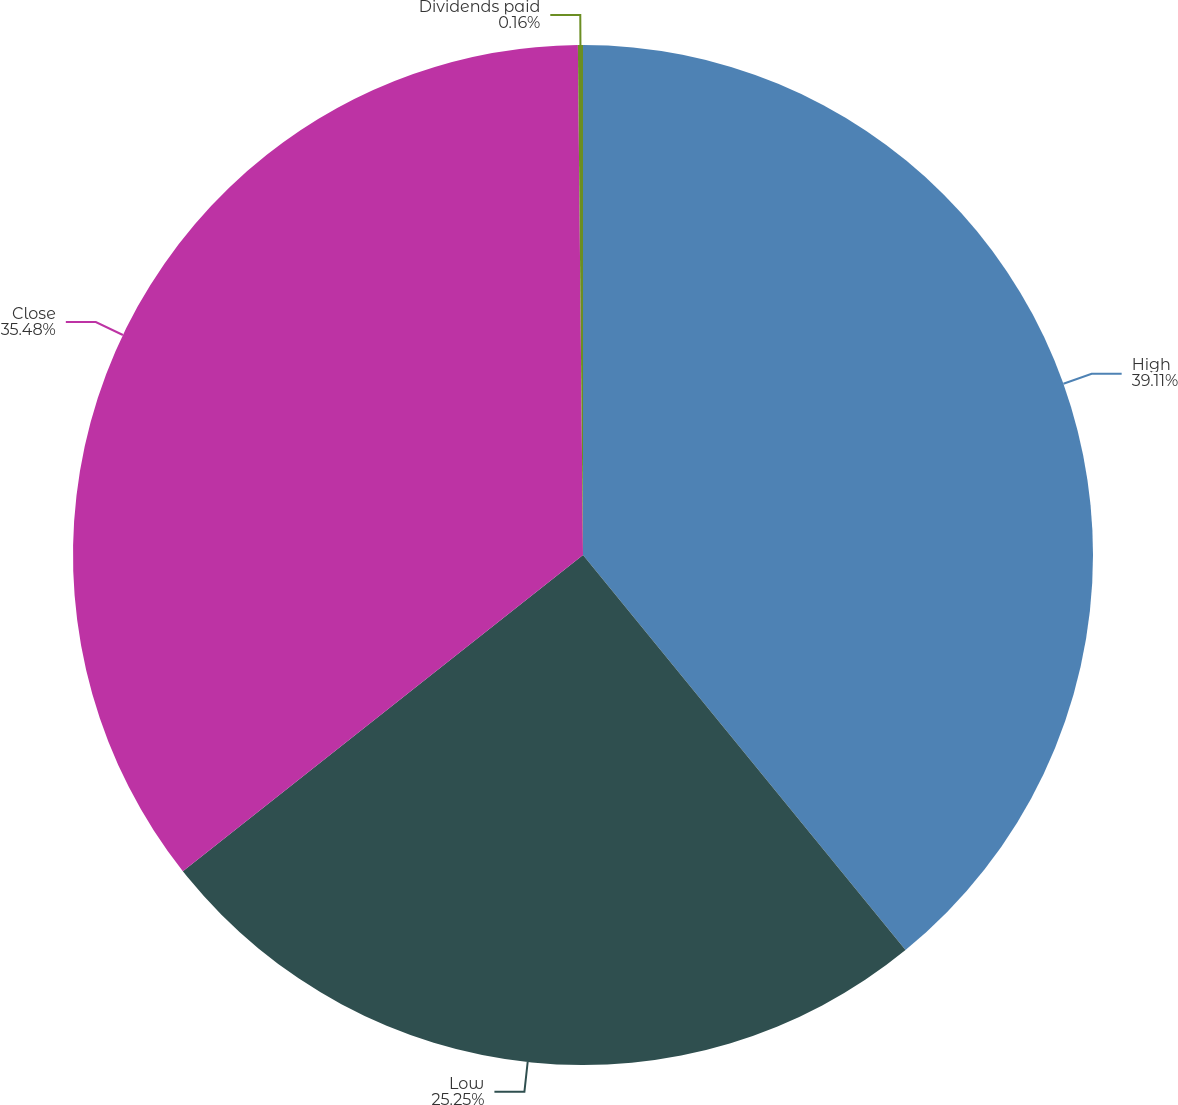<chart> <loc_0><loc_0><loc_500><loc_500><pie_chart><fcel>High<fcel>Low<fcel>Close<fcel>Dividends paid<nl><fcel>39.1%<fcel>25.25%<fcel>35.48%<fcel>0.16%<nl></chart> 